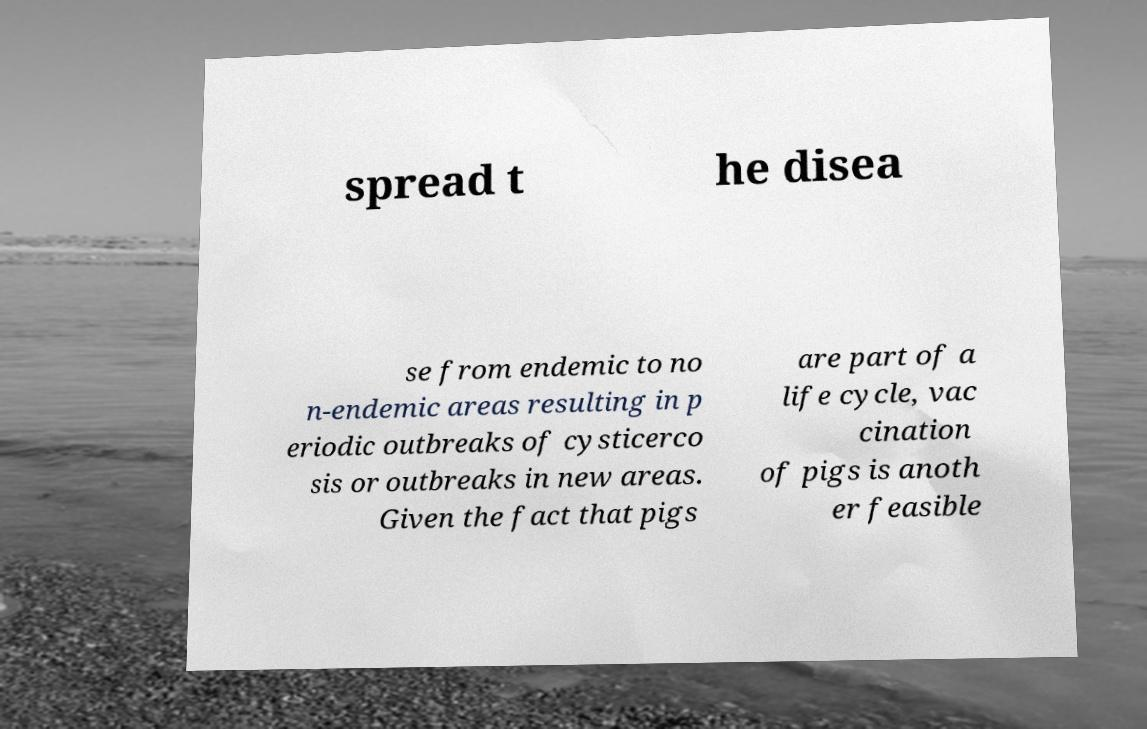For documentation purposes, I need the text within this image transcribed. Could you provide that? spread t he disea se from endemic to no n-endemic areas resulting in p eriodic outbreaks of cysticerco sis or outbreaks in new areas. Given the fact that pigs are part of a life cycle, vac cination of pigs is anoth er feasible 